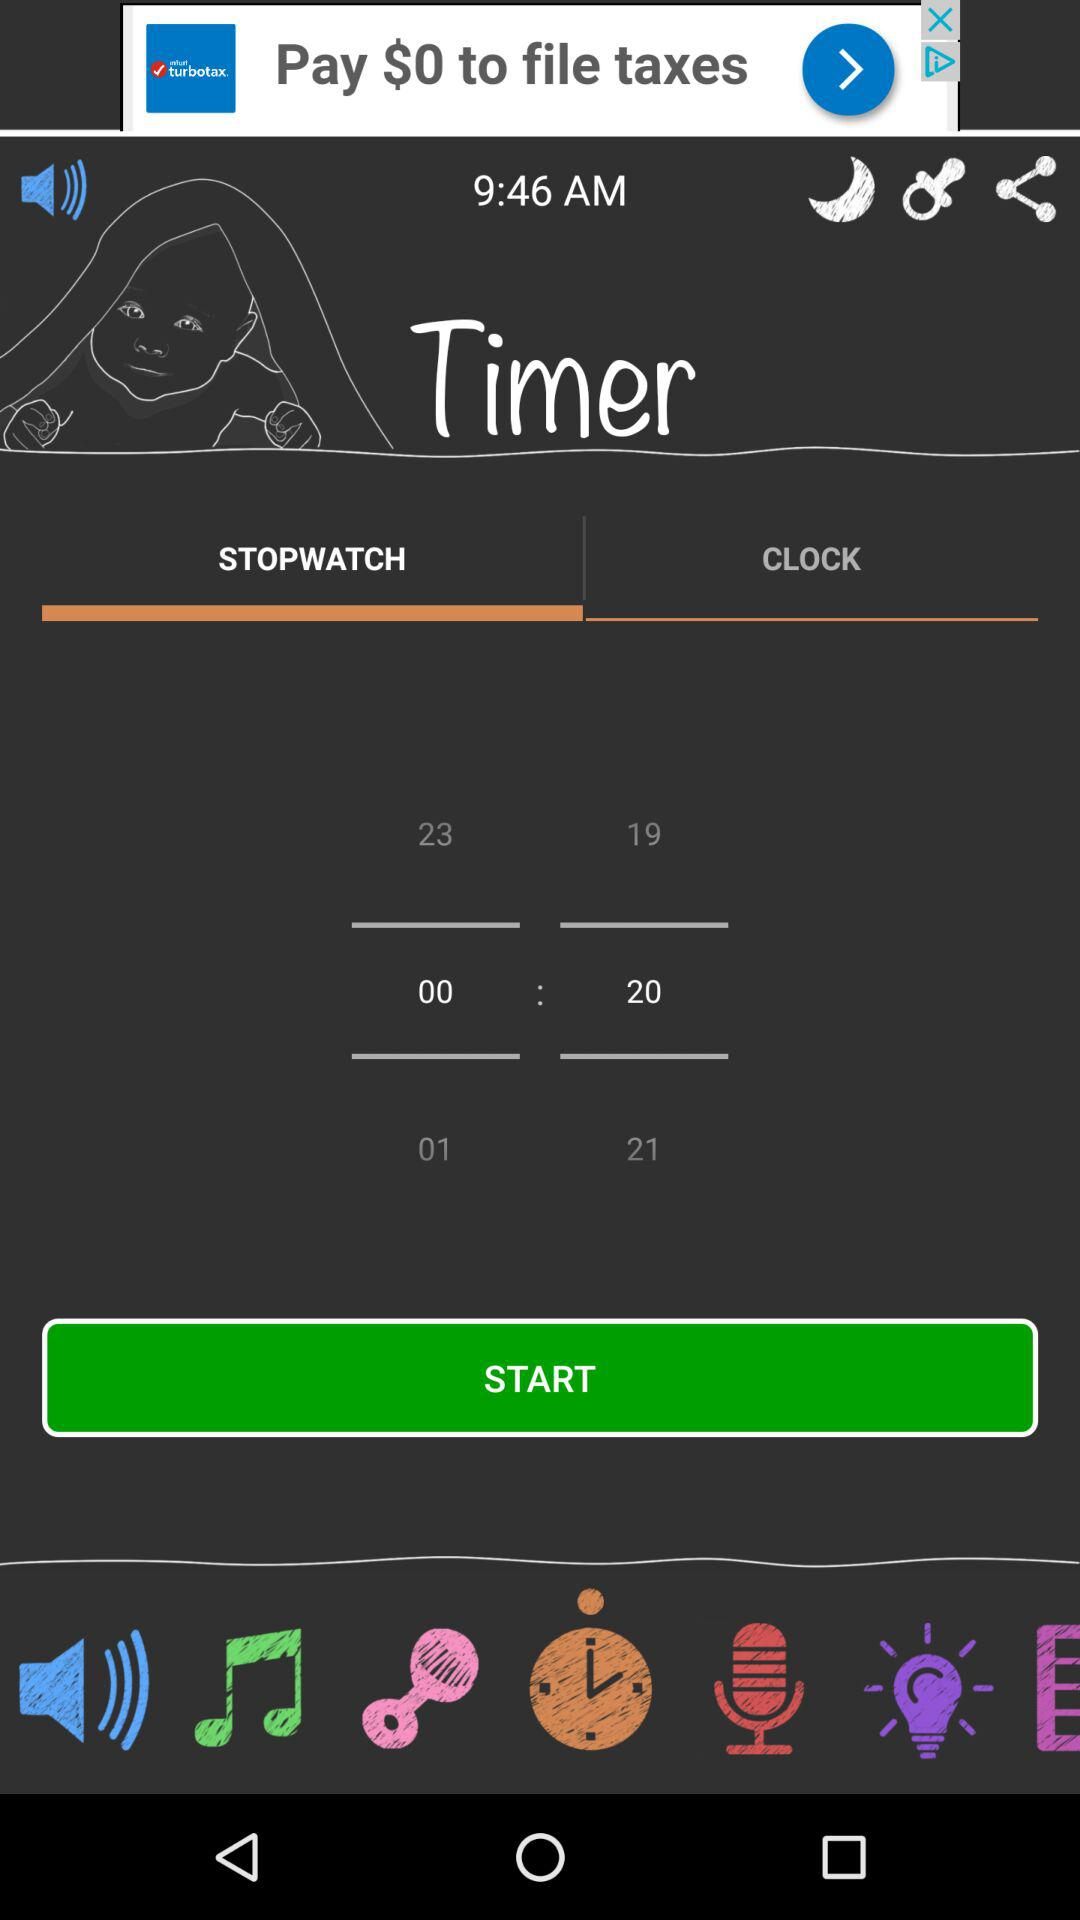Which tab is selected? The selected tabs are "Timer" and "STOPWATCH". 